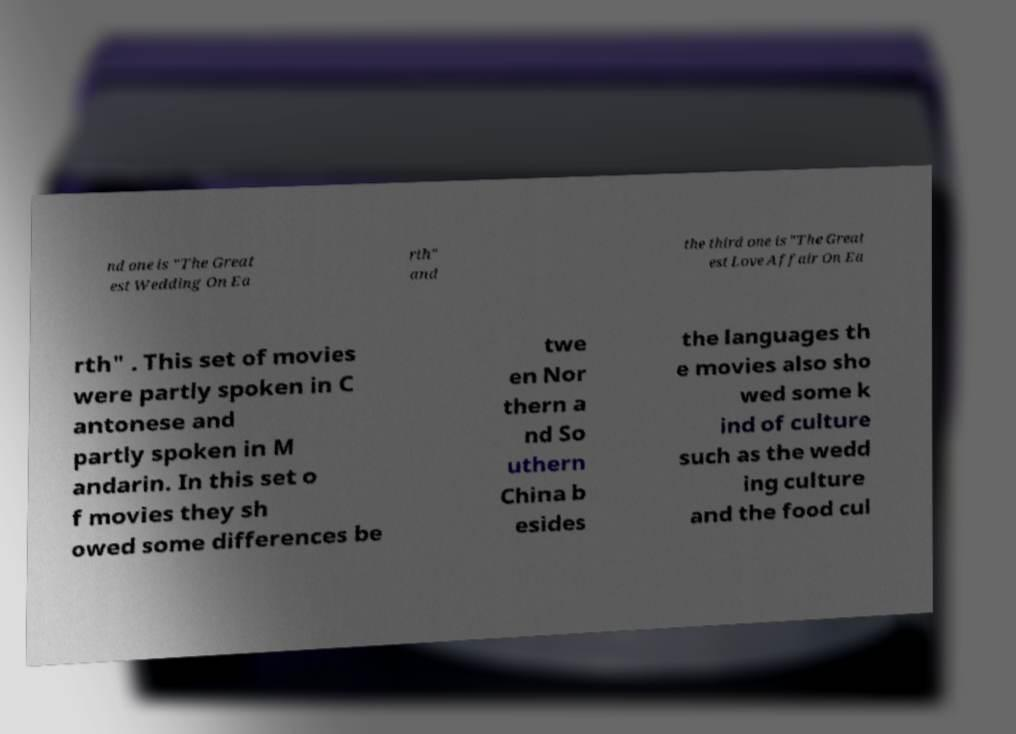Please identify and transcribe the text found in this image. nd one is "The Great est Wedding On Ea rth" and the third one is "The Great est Love Affair On Ea rth" . This set of movies were partly spoken in C antonese and partly spoken in M andarin. In this set o f movies they sh owed some differences be twe en Nor thern a nd So uthern China b esides the languages th e movies also sho wed some k ind of culture such as the wedd ing culture and the food cul 